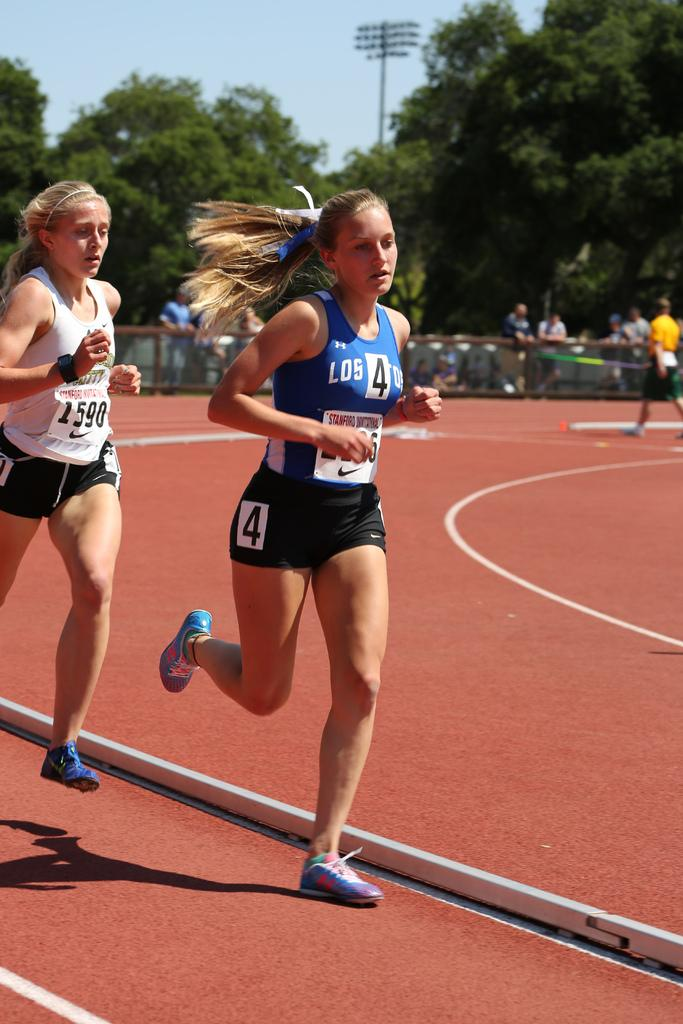<image>
Summarize the visual content of the image. Runner wearing a blue top that has the number 4 on it. 